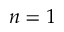<formula> <loc_0><loc_0><loc_500><loc_500>n = 1</formula> 